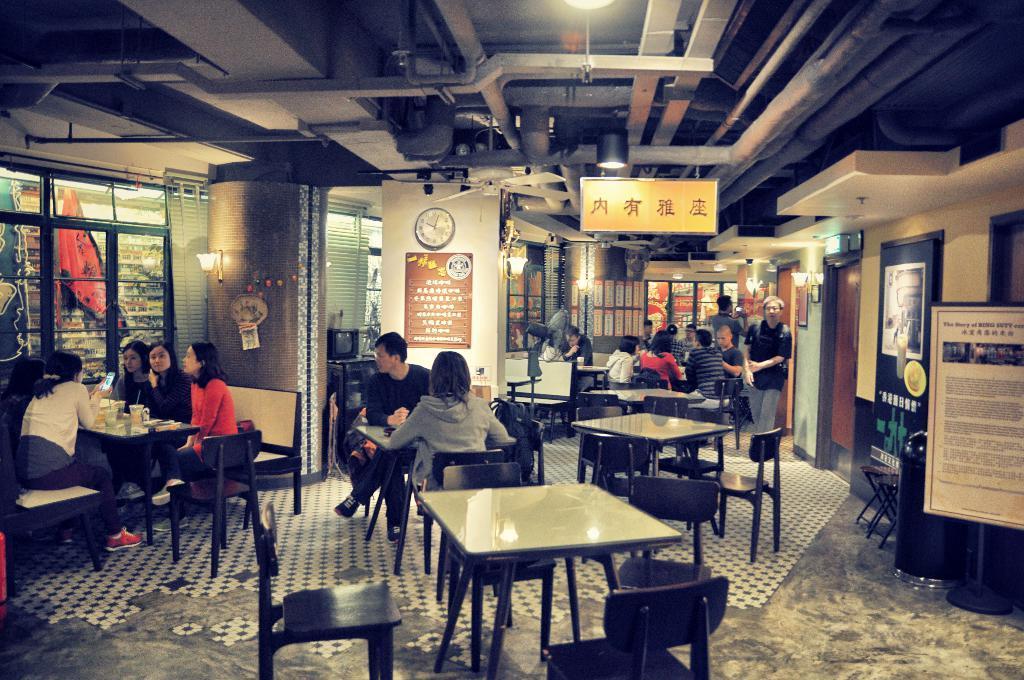Please provide a concise description of this image. There are group of people sitting in a restaurant and there is a table in front of them which has some eatables and drinks on it. 